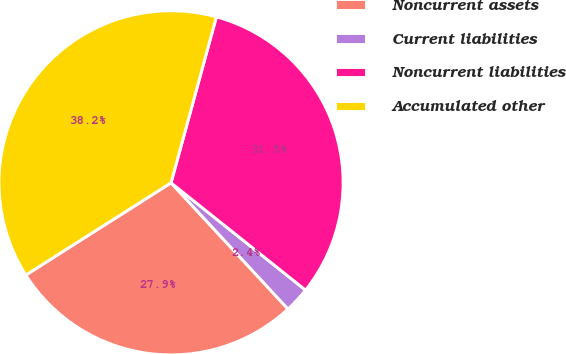Convert chart to OTSL. <chart><loc_0><loc_0><loc_500><loc_500><pie_chart><fcel>Noncurrent assets<fcel>Current liabilities<fcel>Noncurrent liabilities<fcel>Accumulated other<nl><fcel>27.89%<fcel>2.39%<fcel>31.47%<fcel>38.25%<nl></chart> 